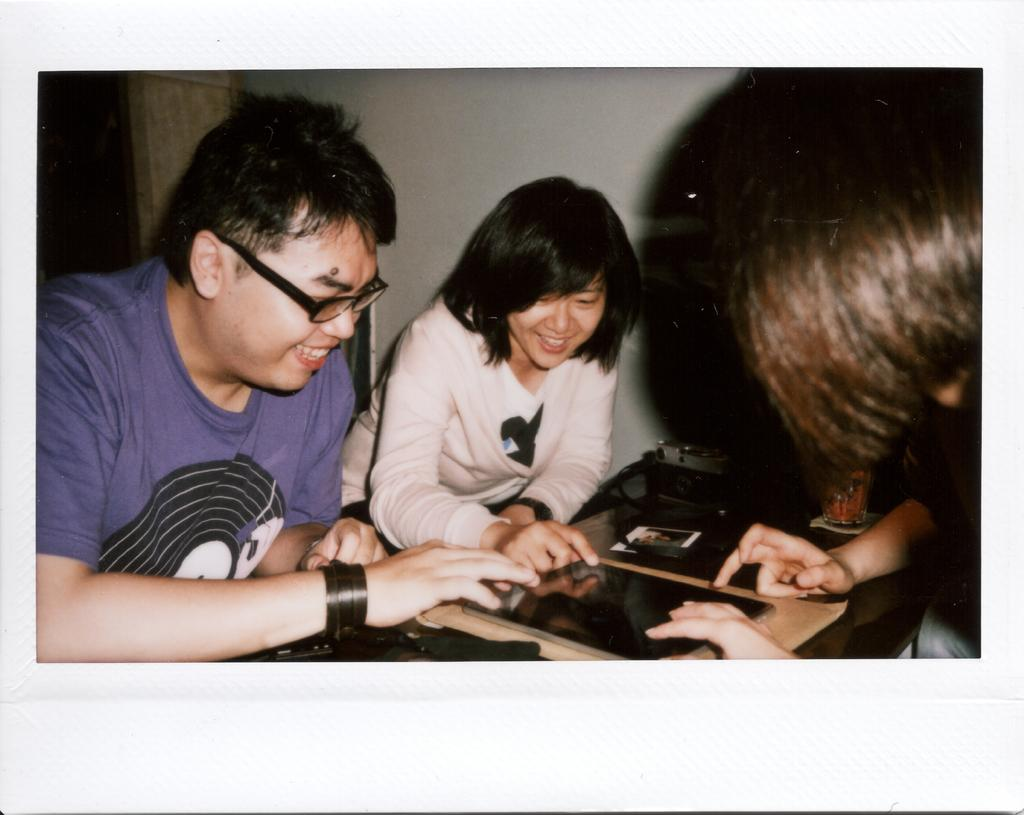Who or what is present in the image? There are people in the image. What is the color of the wall in the image? There is a white color wall in the image. What piece of furniture can be seen in the image? There is a table in the image. What object is placed on the table in the image? There is a photo frame on the table. Can you tell me how many giraffes are in the image? There are no giraffes present in the image. What type of animal is depicted in the photo frame on the table? The photo frame on the table does not show any animals; it likely contains a picture of people or a landscape. 